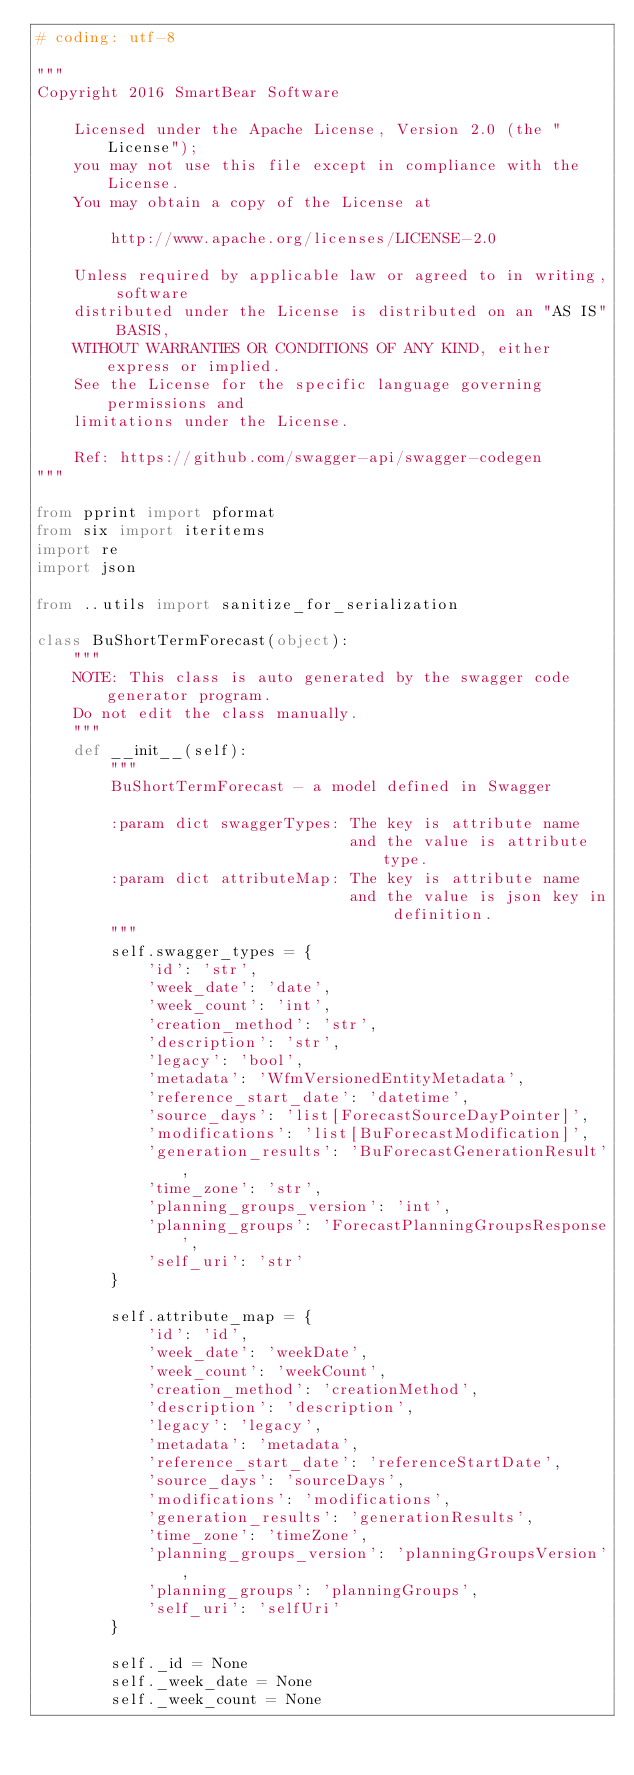<code> <loc_0><loc_0><loc_500><loc_500><_Python_># coding: utf-8

"""
Copyright 2016 SmartBear Software

    Licensed under the Apache License, Version 2.0 (the "License");
    you may not use this file except in compliance with the License.
    You may obtain a copy of the License at

        http://www.apache.org/licenses/LICENSE-2.0

    Unless required by applicable law or agreed to in writing, software
    distributed under the License is distributed on an "AS IS" BASIS,
    WITHOUT WARRANTIES OR CONDITIONS OF ANY KIND, either express or implied.
    See the License for the specific language governing permissions and
    limitations under the License.

    Ref: https://github.com/swagger-api/swagger-codegen
"""

from pprint import pformat
from six import iteritems
import re
import json

from ..utils import sanitize_for_serialization

class BuShortTermForecast(object):
    """
    NOTE: This class is auto generated by the swagger code generator program.
    Do not edit the class manually.
    """
    def __init__(self):
        """
        BuShortTermForecast - a model defined in Swagger

        :param dict swaggerTypes: The key is attribute name
                                  and the value is attribute type.
        :param dict attributeMap: The key is attribute name
                                  and the value is json key in definition.
        """
        self.swagger_types = {
            'id': 'str',
            'week_date': 'date',
            'week_count': 'int',
            'creation_method': 'str',
            'description': 'str',
            'legacy': 'bool',
            'metadata': 'WfmVersionedEntityMetadata',
            'reference_start_date': 'datetime',
            'source_days': 'list[ForecastSourceDayPointer]',
            'modifications': 'list[BuForecastModification]',
            'generation_results': 'BuForecastGenerationResult',
            'time_zone': 'str',
            'planning_groups_version': 'int',
            'planning_groups': 'ForecastPlanningGroupsResponse',
            'self_uri': 'str'
        }

        self.attribute_map = {
            'id': 'id',
            'week_date': 'weekDate',
            'week_count': 'weekCount',
            'creation_method': 'creationMethod',
            'description': 'description',
            'legacy': 'legacy',
            'metadata': 'metadata',
            'reference_start_date': 'referenceStartDate',
            'source_days': 'sourceDays',
            'modifications': 'modifications',
            'generation_results': 'generationResults',
            'time_zone': 'timeZone',
            'planning_groups_version': 'planningGroupsVersion',
            'planning_groups': 'planningGroups',
            'self_uri': 'selfUri'
        }

        self._id = None
        self._week_date = None
        self._week_count = None</code> 